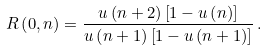Convert formula to latex. <formula><loc_0><loc_0><loc_500><loc_500>R \left ( 0 , n \right ) = \frac { u \left ( n + 2 \right ) \left [ 1 - u \left ( n \right ) \right ] } { u \left ( n + 1 \right ) \left [ 1 - u \left ( n + 1 \right ) \right ] } \, .</formula> 